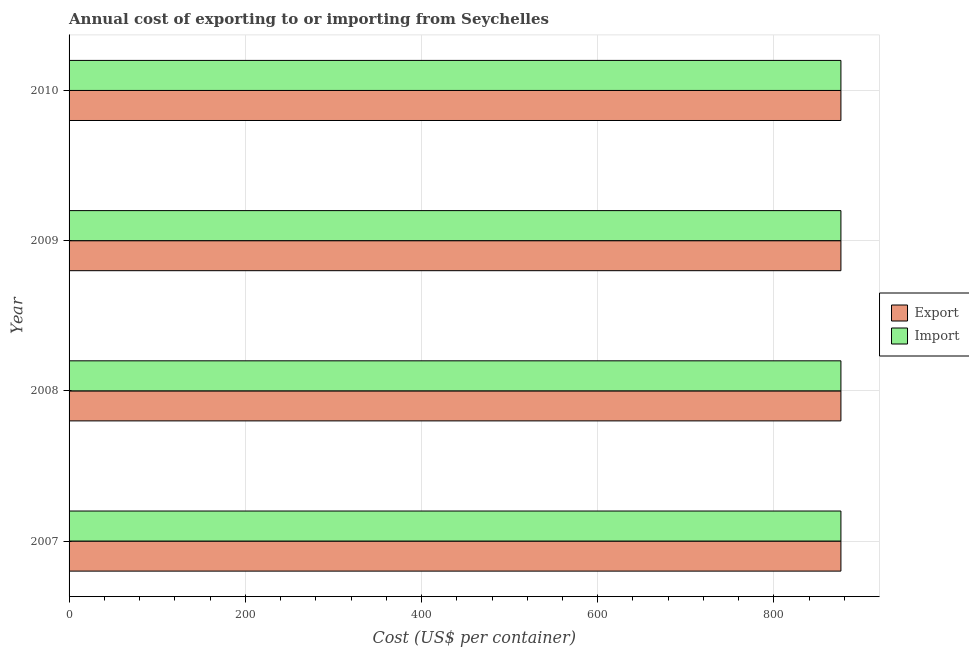How many groups of bars are there?
Offer a terse response. 4. Are the number of bars per tick equal to the number of legend labels?
Offer a terse response. Yes. How many bars are there on the 1st tick from the top?
Ensure brevity in your answer.  2. How many bars are there on the 1st tick from the bottom?
Offer a very short reply. 2. What is the label of the 3rd group of bars from the top?
Your answer should be compact. 2008. What is the import cost in 2008?
Your response must be concise. 876. Across all years, what is the maximum export cost?
Offer a very short reply. 876. Across all years, what is the minimum import cost?
Keep it short and to the point. 876. In which year was the export cost maximum?
Provide a short and direct response. 2007. What is the total import cost in the graph?
Your answer should be compact. 3504. What is the difference between the import cost in 2010 and the export cost in 2007?
Your answer should be very brief. 0. What is the average export cost per year?
Offer a very short reply. 876. In how many years, is the export cost greater than 520 US$?
Your answer should be compact. 4. Is the import cost in 2007 less than that in 2010?
Your response must be concise. No. What is the difference between the highest and the second highest import cost?
Ensure brevity in your answer.  0. What is the difference between the highest and the lowest import cost?
Ensure brevity in your answer.  0. What does the 2nd bar from the top in 2010 represents?
Your response must be concise. Export. What does the 1st bar from the bottom in 2009 represents?
Provide a succinct answer. Export. How many bars are there?
Make the answer very short. 8. Are all the bars in the graph horizontal?
Give a very brief answer. Yes. What is the difference between two consecutive major ticks on the X-axis?
Make the answer very short. 200. How many legend labels are there?
Make the answer very short. 2. How are the legend labels stacked?
Keep it short and to the point. Vertical. What is the title of the graph?
Your answer should be very brief. Annual cost of exporting to or importing from Seychelles. Does "Merchandise exports" appear as one of the legend labels in the graph?
Keep it short and to the point. No. What is the label or title of the X-axis?
Make the answer very short. Cost (US$ per container). What is the label or title of the Y-axis?
Make the answer very short. Year. What is the Cost (US$ per container) of Export in 2007?
Give a very brief answer. 876. What is the Cost (US$ per container) in Import in 2007?
Your answer should be very brief. 876. What is the Cost (US$ per container) of Export in 2008?
Offer a very short reply. 876. What is the Cost (US$ per container) of Import in 2008?
Provide a succinct answer. 876. What is the Cost (US$ per container) of Export in 2009?
Your response must be concise. 876. What is the Cost (US$ per container) of Import in 2009?
Your answer should be very brief. 876. What is the Cost (US$ per container) of Export in 2010?
Make the answer very short. 876. What is the Cost (US$ per container) in Import in 2010?
Make the answer very short. 876. Across all years, what is the maximum Cost (US$ per container) in Export?
Offer a terse response. 876. Across all years, what is the maximum Cost (US$ per container) of Import?
Your answer should be very brief. 876. Across all years, what is the minimum Cost (US$ per container) in Export?
Your answer should be compact. 876. Across all years, what is the minimum Cost (US$ per container) of Import?
Provide a short and direct response. 876. What is the total Cost (US$ per container) of Export in the graph?
Your answer should be very brief. 3504. What is the total Cost (US$ per container) of Import in the graph?
Offer a very short reply. 3504. What is the difference between the Cost (US$ per container) of Export in 2007 and that in 2008?
Keep it short and to the point. 0. What is the difference between the Cost (US$ per container) of Export in 2007 and that in 2009?
Ensure brevity in your answer.  0. What is the difference between the Cost (US$ per container) in Import in 2007 and that in 2009?
Ensure brevity in your answer.  0. What is the difference between the Cost (US$ per container) in Export in 2007 and that in 2010?
Keep it short and to the point. 0. What is the difference between the Cost (US$ per container) in Import in 2009 and that in 2010?
Provide a short and direct response. 0. What is the difference between the Cost (US$ per container) of Export in 2007 and the Cost (US$ per container) of Import in 2008?
Your answer should be very brief. 0. What is the difference between the Cost (US$ per container) of Export in 2007 and the Cost (US$ per container) of Import in 2010?
Make the answer very short. 0. What is the difference between the Cost (US$ per container) in Export in 2008 and the Cost (US$ per container) in Import in 2010?
Provide a succinct answer. 0. What is the average Cost (US$ per container) in Export per year?
Offer a very short reply. 876. What is the average Cost (US$ per container) of Import per year?
Provide a short and direct response. 876. In the year 2009, what is the difference between the Cost (US$ per container) of Export and Cost (US$ per container) of Import?
Offer a very short reply. 0. In the year 2010, what is the difference between the Cost (US$ per container) in Export and Cost (US$ per container) in Import?
Make the answer very short. 0. What is the ratio of the Cost (US$ per container) of Export in 2007 to that in 2008?
Provide a succinct answer. 1. What is the ratio of the Cost (US$ per container) of Export in 2007 to that in 2009?
Your answer should be very brief. 1. What is the ratio of the Cost (US$ per container) in Import in 2007 to that in 2009?
Give a very brief answer. 1. What is the ratio of the Cost (US$ per container) in Import in 2007 to that in 2010?
Ensure brevity in your answer.  1. What is the ratio of the Cost (US$ per container) in Export in 2008 to that in 2009?
Keep it short and to the point. 1. What is the ratio of the Cost (US$ per container) of Import in 2008 to that in 2009?
Keep it short and to the point. 1. What is the ratio of the Cost (US$ per container) in Import in 2008 to that in 2010?
Provide a short and direct response. 1. What is the ratio of the Cost (US$ per container) in Export in 2009 to that in 2010?
Ensure brevity in your answer.  1. What is the ratio of the Cost (US$ per container) of Import in 2009 to that in 2010?
Offer a very short reply. 1. What is the difference between the highest and the second highest Cost (US$ per container) in Import?
Keep it short and to the point. 0. What is the difference between the highest and the lowest Cost (US$ per container) in Export?
Provide a short and direct response. 0. What is the difference between the highest and the lowest Cost (US$ per container) of Import?
Your answer should be compact. 0. 